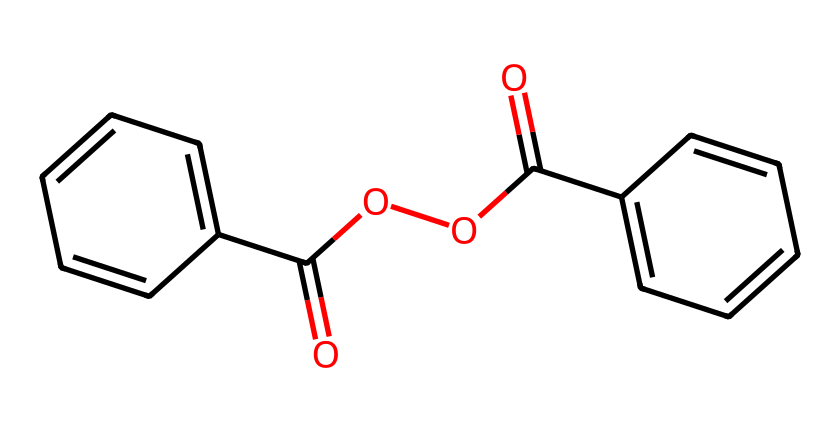What is the molecular formula of benzoyl peroxide? To find the molecular formula, we count each type of atom in the structure. The SMILES indicates there are two benzene rings (C6H5) and a peroxide group (O-O). The final count gives C14H10O4.
Answer: C14H10O4 How many carbon atoms are present in the chemical? The chemical structure includes two phenyl rings which have six carbon atoms each, totaling twelve, plus two additional carbons in the peroxide structure, giving fourteen.
Answer: 14 What functional groups are present in this chemical? Analyzing the structure, the main functional groups visible are the carboxylate (from the carboxylic acid part) and the peroxide (O-O bond). These are critical for its reactivity.
Answer: carboxylate and peroxide Which part of the chemical is responsible for its acne treatment properties? The presence of the peroxide functional group (O-O) is known to have antibacterial properties, making it effective in treating acne by killing acne-causing bacteria.
Answer: peroxide How does this chemical affect skin? Benzoyl peroxide works as an exfoliant by releasing oxygen, which kills bacteria and encourages the shedding of dead skin cells, helping to reduce acne.
Answer: exfoliant What type of chemical structure is demonstrated in this compound? The compound exhibits an organic structure characterized by aromatic rings (benzene) and a peroxide linkage, which is typical in many cosmetic chemicals for effective treatment.
Answer: organic structure 